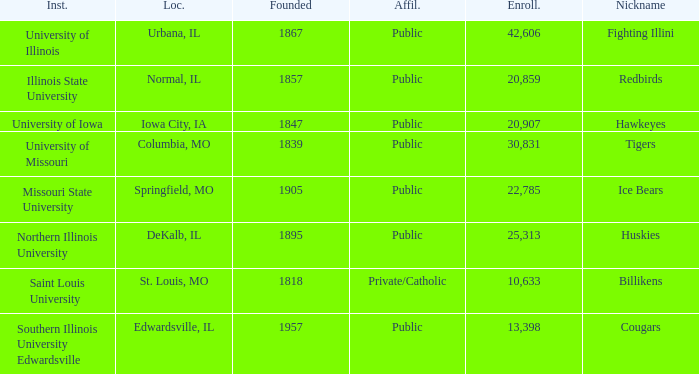Which institution is private/catholic? Saint Louis University. 